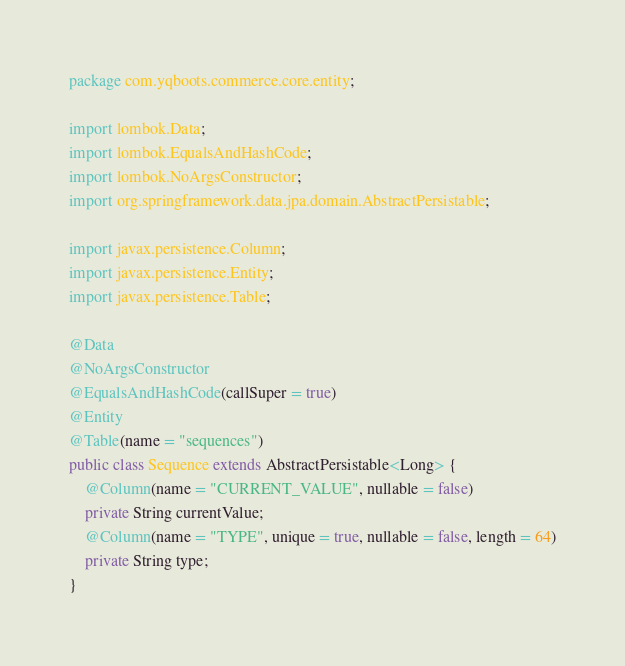Convert code to text. <code><loc_0><loc_0><loc_500><loc_500><_Java_>package com.yqboots.commerce.core.entity;

import lombok.Data;
import lombok.EqualsAndHashCode;
import lombok.NoArgsConstructor;
import org.springframework.data.jpa.domain.AbstractPersistable;

import javax.persistence.Column;
import javax.persistence.Entity;
import javax.persistence.Table;

@Data
@NoArgsConstructor
@EqualsAndHashCode(callSuper = true)
@Entity
@Table(name = "sequences")
public class Sequence extends AbstractPersistable<Long> {
    @Column(name = "CURRENT_VALUE", nullable = false)
    private String currentValue;
    @Column(name = "TYPE", unique = true, nullable = false, length = 64)
    private String type;
}
</code> 